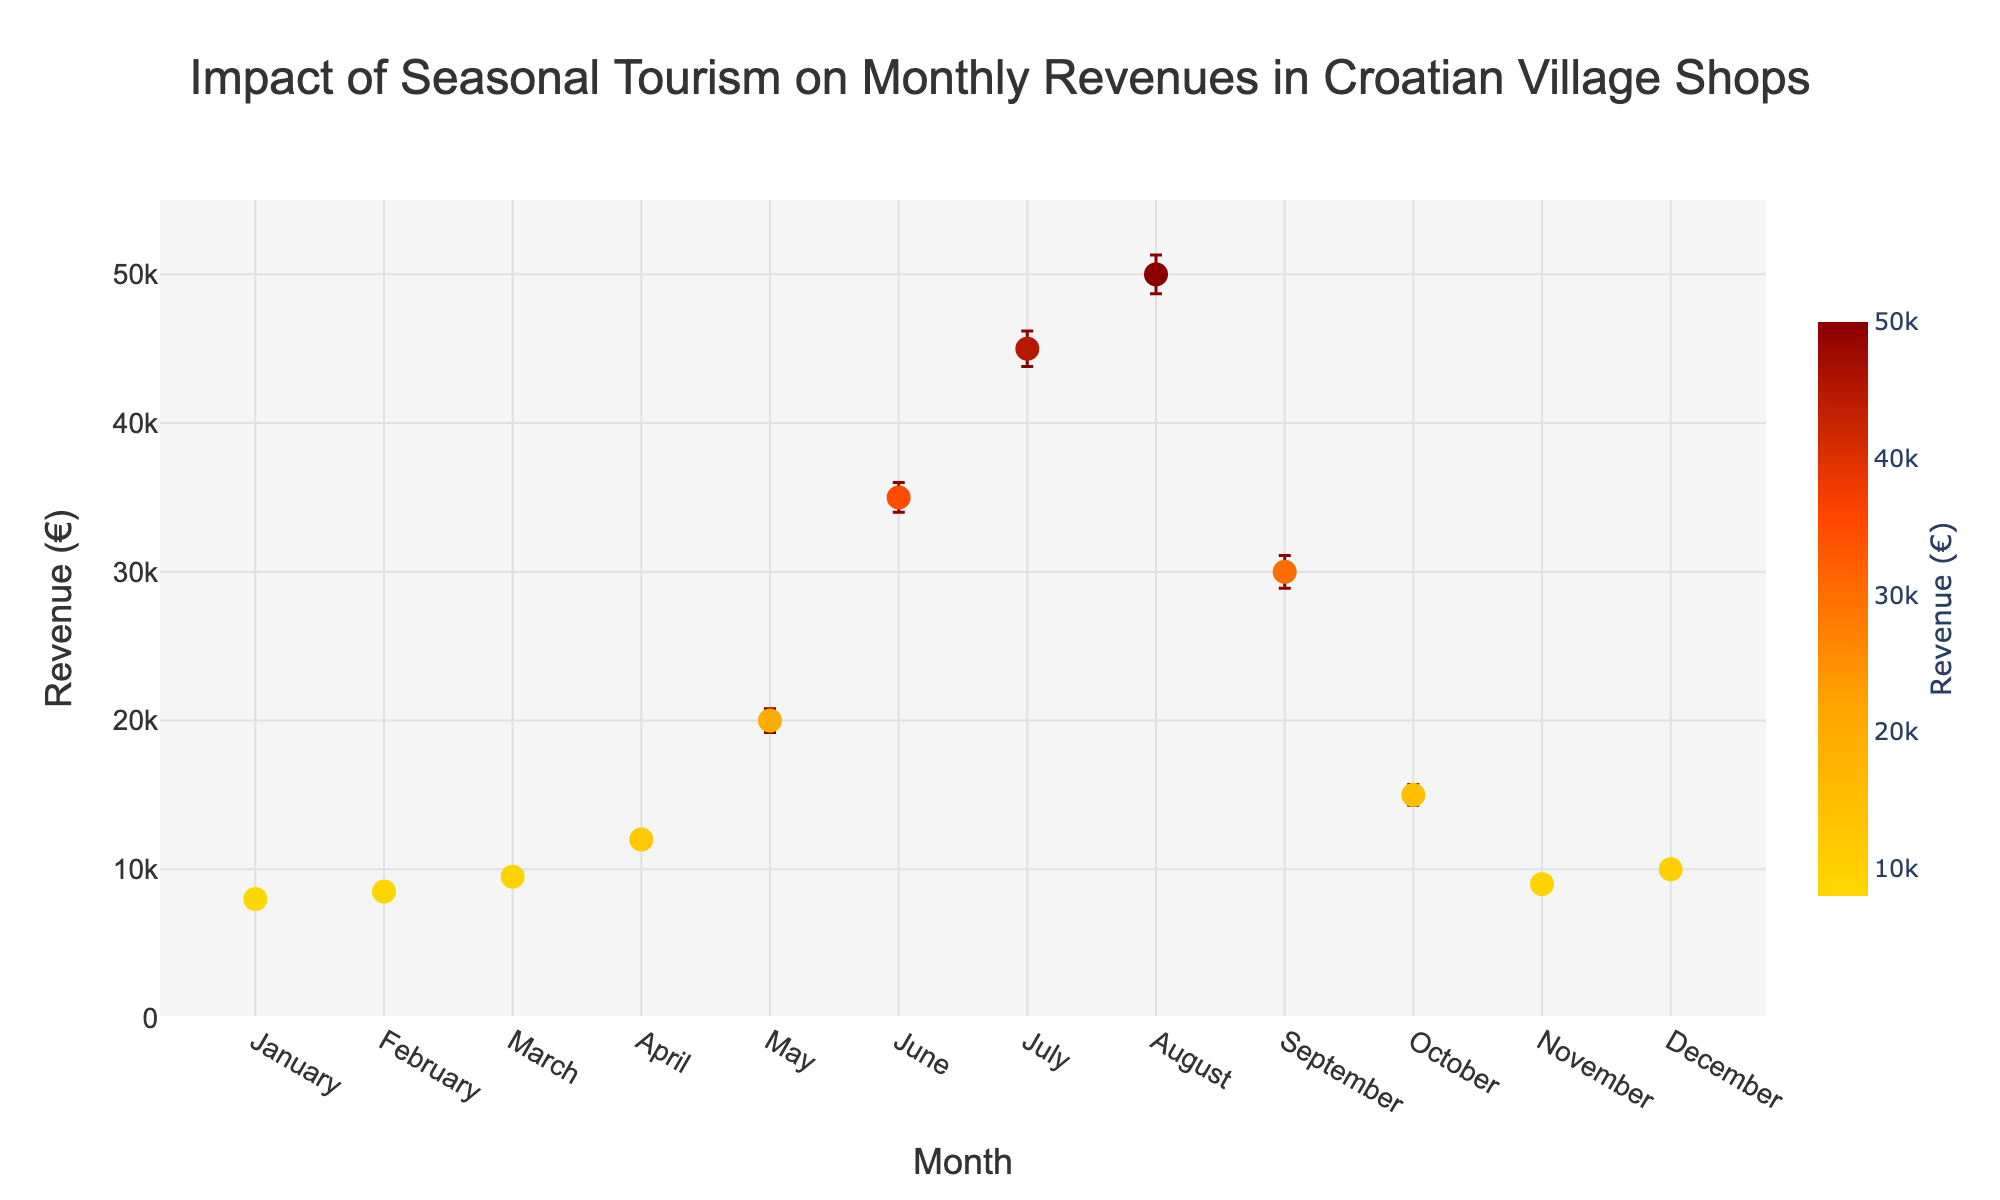What is the title of the figure? The title of the figure is typically displayed at the top of the plot. By looking at the top of the figure, you can see the heading.
Answer: Impact of Seasonal Tourism on Monthly Revenues in Croatian Village Shops Which month shows the highest revenue? The highest revenue is represented by the tallest point on the y-axis. By examining the plot, the tallest point is for the month of August.
Answer: August What are the revenue values for June and July, and which one is higher? Find the points corresponding to June and July on the x-axis and compare their revenue values on the y-axis. June's revenue is 35,000€, and July’s revenue is 45,000€.
Answer: July is higher What is the range of revenue values from the lowest to the highest month? The lowest month is January with 8,000€, and the highest month is August with 50,000€. The range is calculated by subtracting the lowest value from the highest.
Answer: 42,000€ What's the average revenue in the first quarter (January to March)? Add the revenues for January (8,000€), February (8,500€), and March (9,500€). Then, divide the sum by the number of months to find the average. (8000 + 8500 + 9500) / 3 = 26,000 / 3
Answer: 8,667€ Which month has the largest error bar? The error bars are visible vertical lines extending from each point. Identify which month has the longest line.
Answer: August Between which months is the difference in revenue the greatest? Identify the months with the highest and lowest revenues. August has the highest revenue (50,000€) and January the lowest (8,000€), so the difference is greatest between these two months.
Answer: Between August and January How does the revenue in October compare to November? Locate the points for October and November and compare their revenues on the y-axis. October has 15,000€, and November has 9,000€.
Answer: October is higher What trend do you observe in the revenues from April to September? Look at the revenue points from April to September and observe the pattern. Revenues increase from April (12,000€) to peak in August (50,000€) and then drop in September (30,000€).
Answer: Increasing then decreasing What's the revenue variance in the summer months (June, July, August)? Sum the squared differences between each month’s revenue and the average revenue of these months, then divide by the number of data points. The average revenue is (35000 + 45000 + 50000) / 3 = 43,333€. Variance = [(35000-43333)^2 + (45000-43333)^2 + (50000-43333)^2] / 3
Answer: 55,555,556 